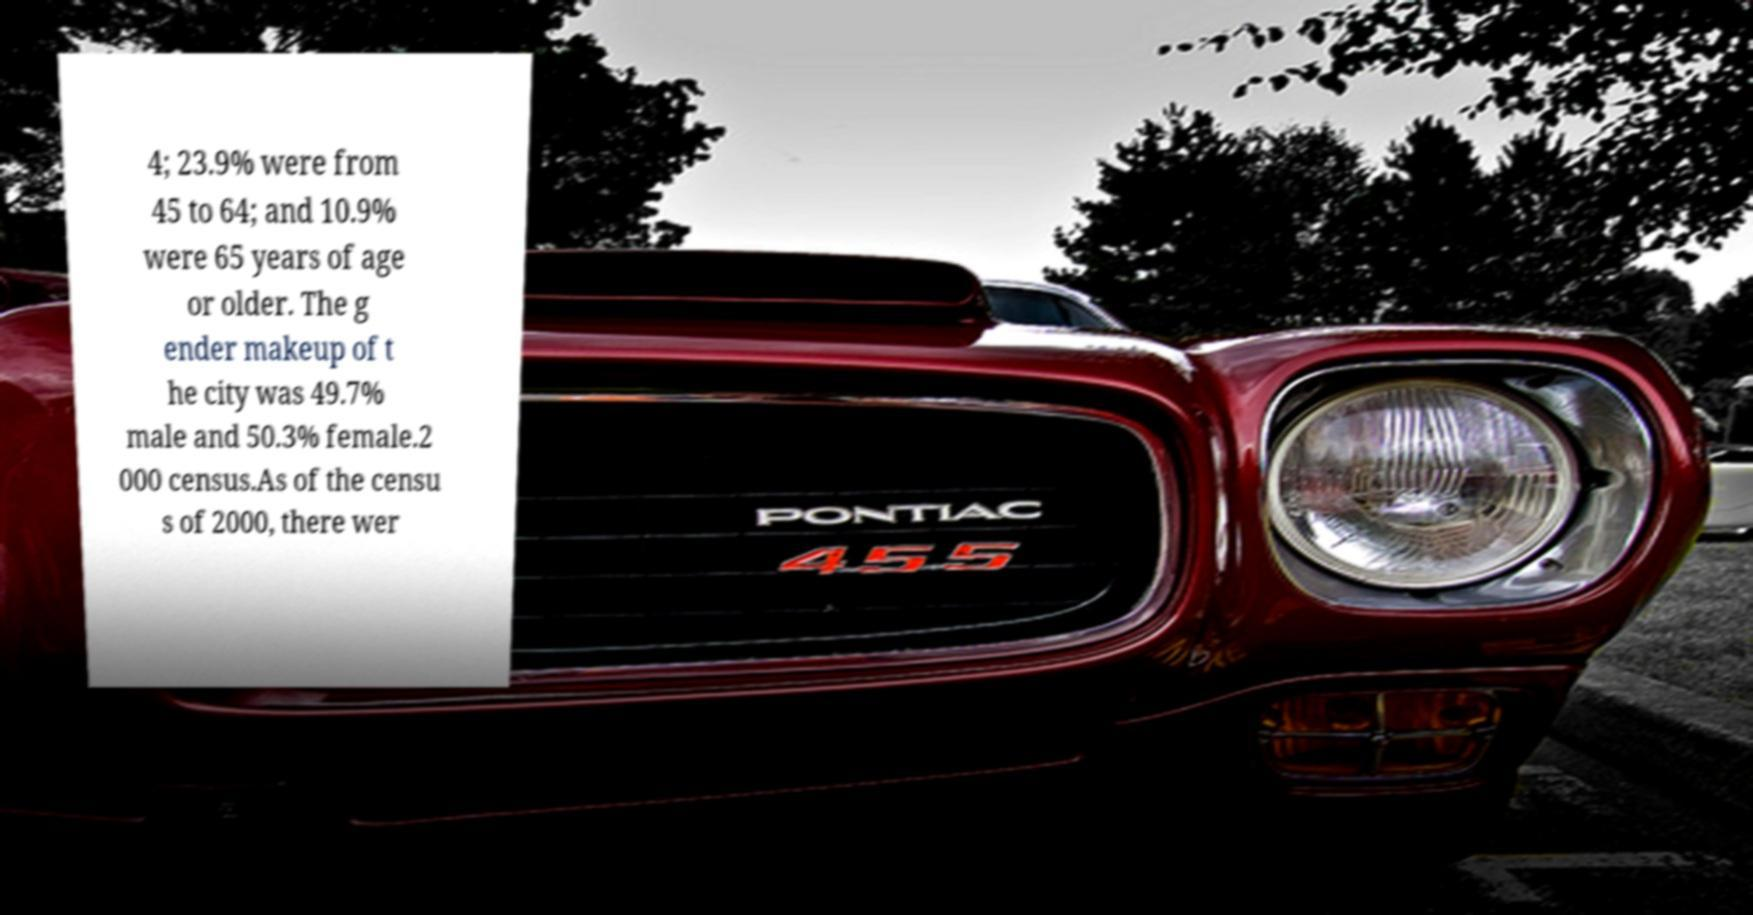Can you read and provide the text displayed in the image?This photo seems to have some interesting text. Can you extract and type it out for me? 4; 23.9% were from 45 to 64; and 10.9% were 65 years of age or older. The g ender makeup of t he city was 49.7% male and 50.3% female.2 000 census.As of the censu s of 2000, there wer 